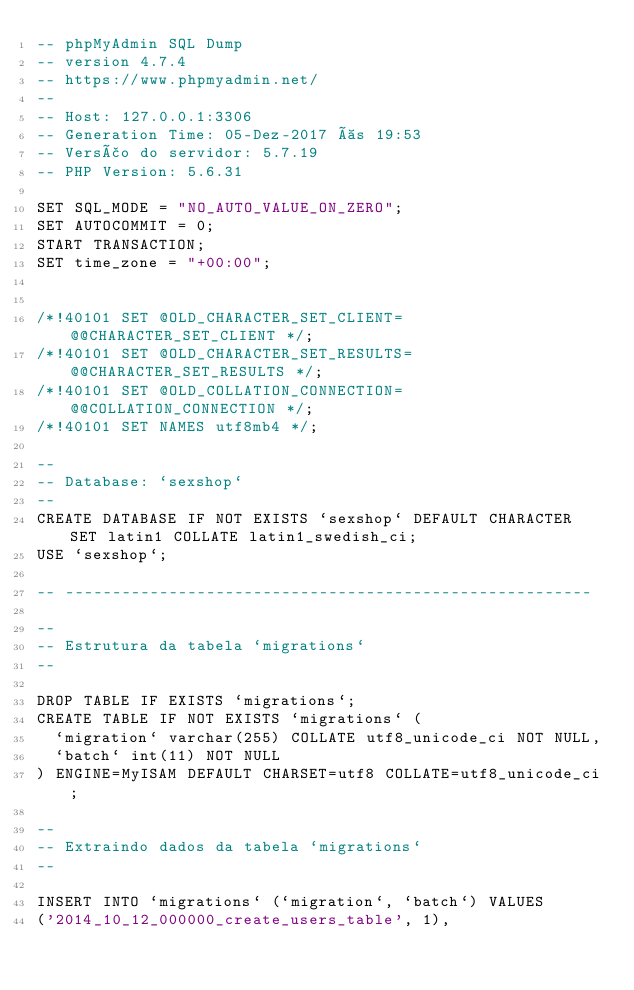Convert code to text. <code><loc_0><loc_0><loc_500><loc_500><_SQL_>-- phpMyAdmin SQL Dump
-- version 4.7.4
-- https://www.phpmyadmin.net/
--
-- Host: 127.0.0.1:3306
-- Generation Time: 05-Dez-2017 às 19:53
-- Versão do servidor: 5.7.19
-- PHP Version: 5.6.31

SET SQL_MODE = "NO_AUTO_VALUE_ON_ZERO";
SET AUTOCOMMIT = 0;
START TRANSACTION;
SET time_zone = "+00:00";


/*!40101 SET @OLD_CHARACTER_SET_CLIENT=@@CHARACTER_SET_CLIENT */;
/*!40101 SET @OLD_CHARACTER_SET_RESULTS=@@CHARACTER_SET_RESULTS */;
/*!40101 SET @OLD_COLLATION_CONNECTION=@@COLLATION_CONNECTION */;
/*!40101 SET NAMES utf8mb4 */;

--
-- Database: `sexshop`
--
CREATE DATABASE IF NOT EXISTS `sexshop` DEFAULT CHARACTER SET latin1 COLLATE latin1_swedish_ci;
USE `sexshop`;

-- --------------------------------------------------------

--
-- Estrutura da tabela `migrations`
--

DROP TABLE IF EXISTS `migrations`;
CREATE TABLE IF NOT EXISTS `migrations` (
  `migration` varchar(255) COLLATE utf8_unicode_ci NOT NULL,
  `batch` int(11) NOT NULL
) ENGINE=MyISAM DEFAULT CHARSET=utf8 COLLATE=utf8_unicode_ci;

--
-- Extraindo dados da tabela `migrations`
--

INSERT INTO `migrations` (`migration`, `batch`) VALUES
('2014_10_12_000000_create_users_table', 1),</code> 